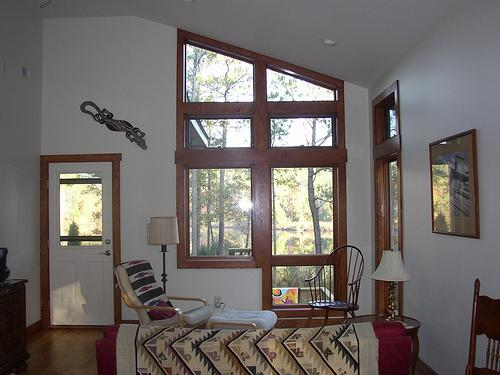Question: what color are the walls?
Choices:
A. Grey.
B. Yellow.
C. White.
D. Blue.
Answer with the letter. Answer: C Question: where is this located?
Choices:
A. In the forest.
B. In a field.
C. At the park.
D. In the woods.
Answer with the letter. Answer: D 